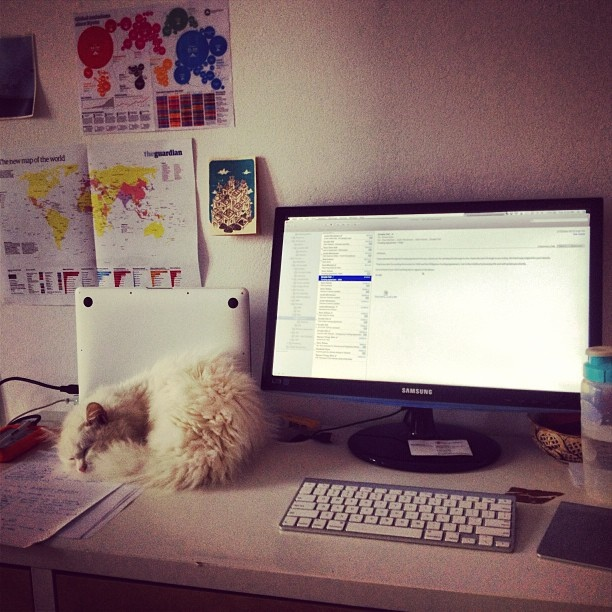Describe the objects in this image and their specific colors. I can see tv in purple, beige, black, lightgray, and darkgray tones, cat in purple, tan, and gray tones, keyboard in purple, darkgray, brown, gray, and black tones, bottle in purple and gray tones, and bowl in purple, black, maroon, and brown tones in this image. 